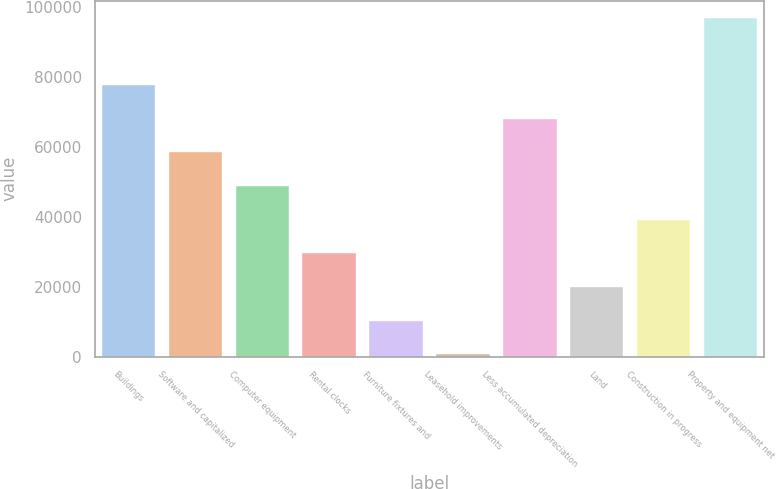<chart> <loc_0><loc_0><loc_500><loc_500><bar_chart><fcel>Buildings<fcel>Software and capitalized<fcel>Computer equipment<fcel>Rental clocks<fcel>Furniture fixtures and<fcel>Leasehold improvements<fcel>Less accumulated depreciation<fcel>Land<fcel>Construction in progress<fcel>Property and equipment net<nl><fcel>77614.4<fcel>58380.8<fcel>48764<fcel>29530.4<fcel>10296.8<fcel>680<fcel>67997.6<fcel>19913.6<fcel>39147.2<fcel>96848<nl></chart> 